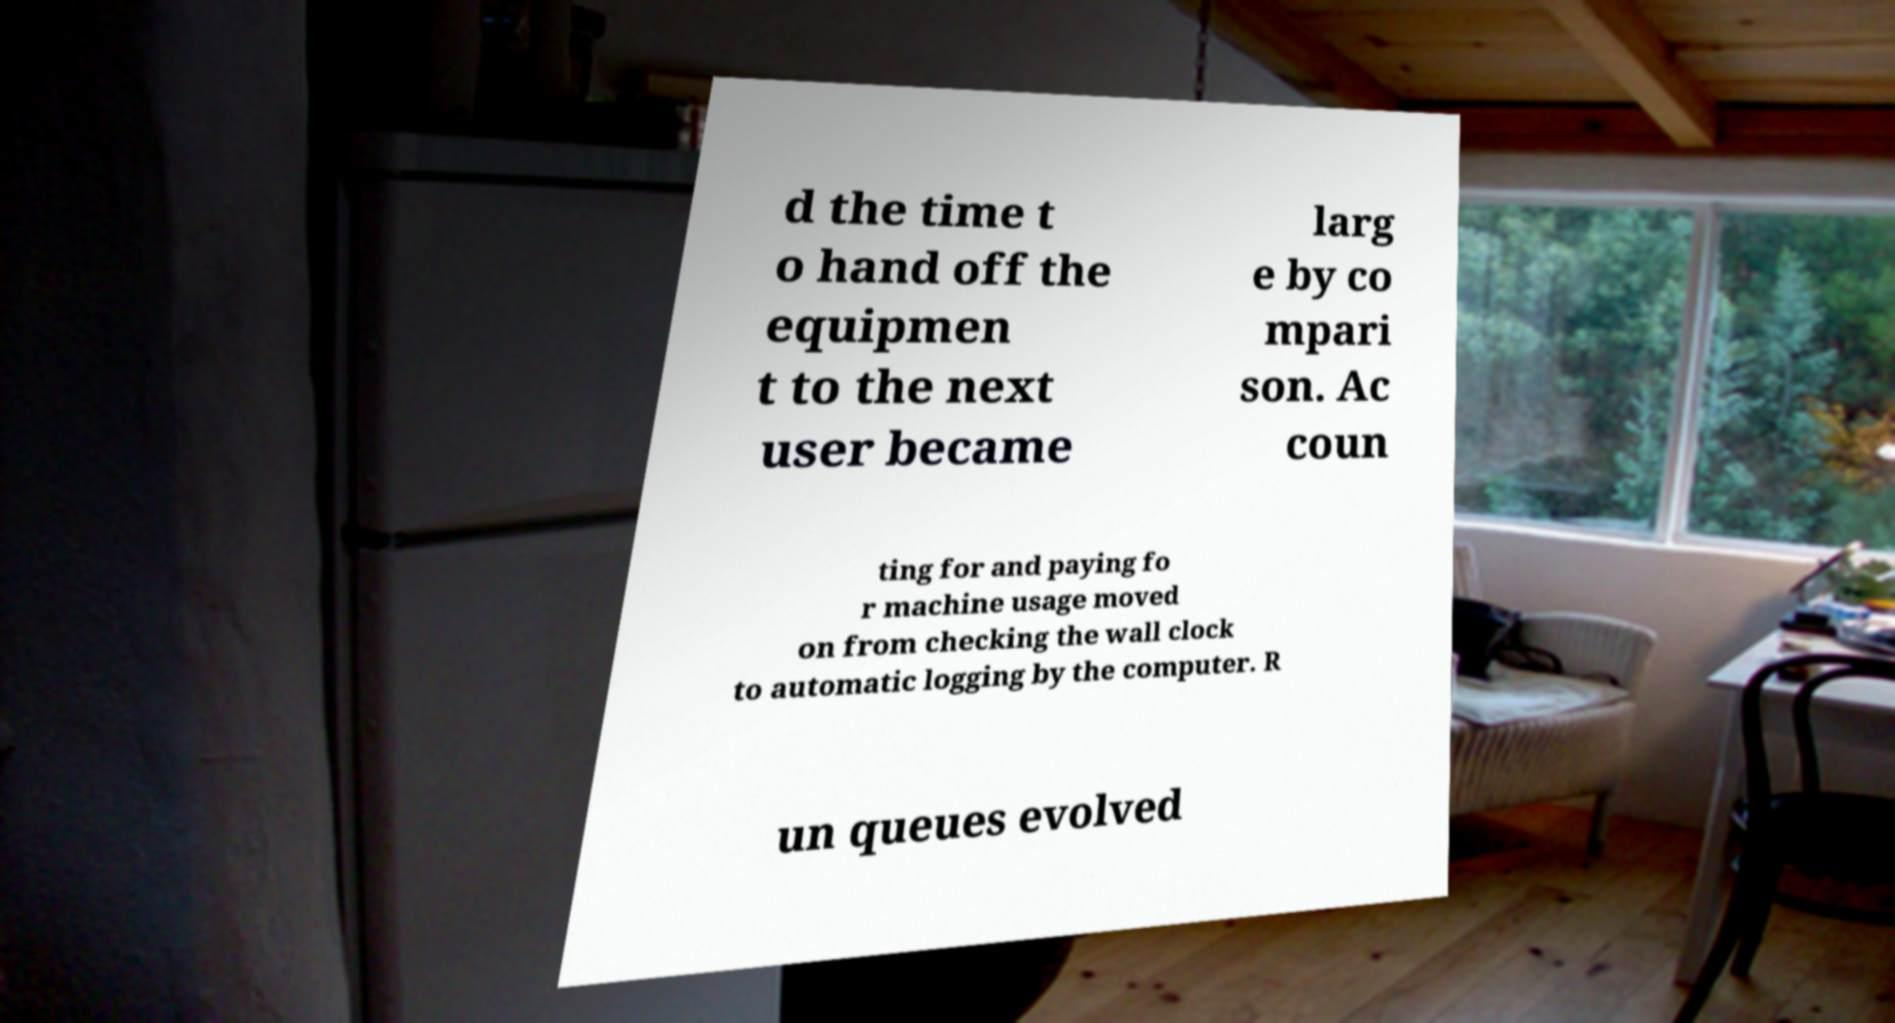There's text embedded in this image that I need extracted. Can you transcribe it verbatim? d the time t o hand off the equipmen t to the next user became larg e by co mpari son. Ac coun ting for and paying fo r machine usage moved on from checking the wall clock to automatic logging by the computer. R un queues evolved 